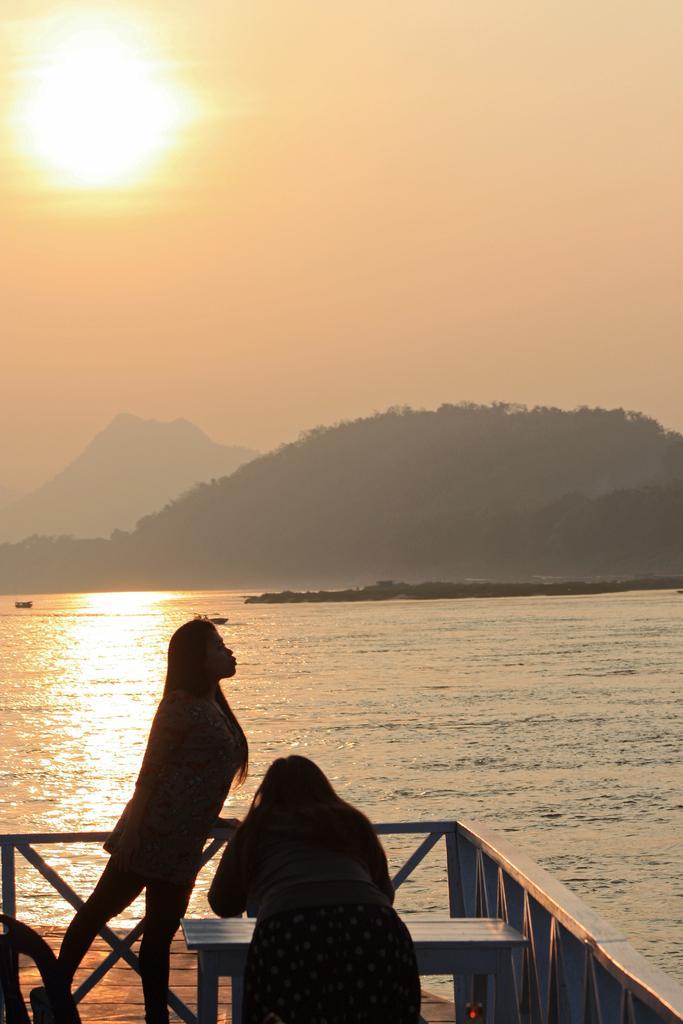Please provide a concise description of this image. In this picture we can see two people and a bench on a platform and in the background we can see water, mountains, sky. 